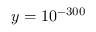<formula> <loc_0><loc_0><loc_500><loc_500>{ y = 1 0 ^ { - 3 0 0 } }</formula> 